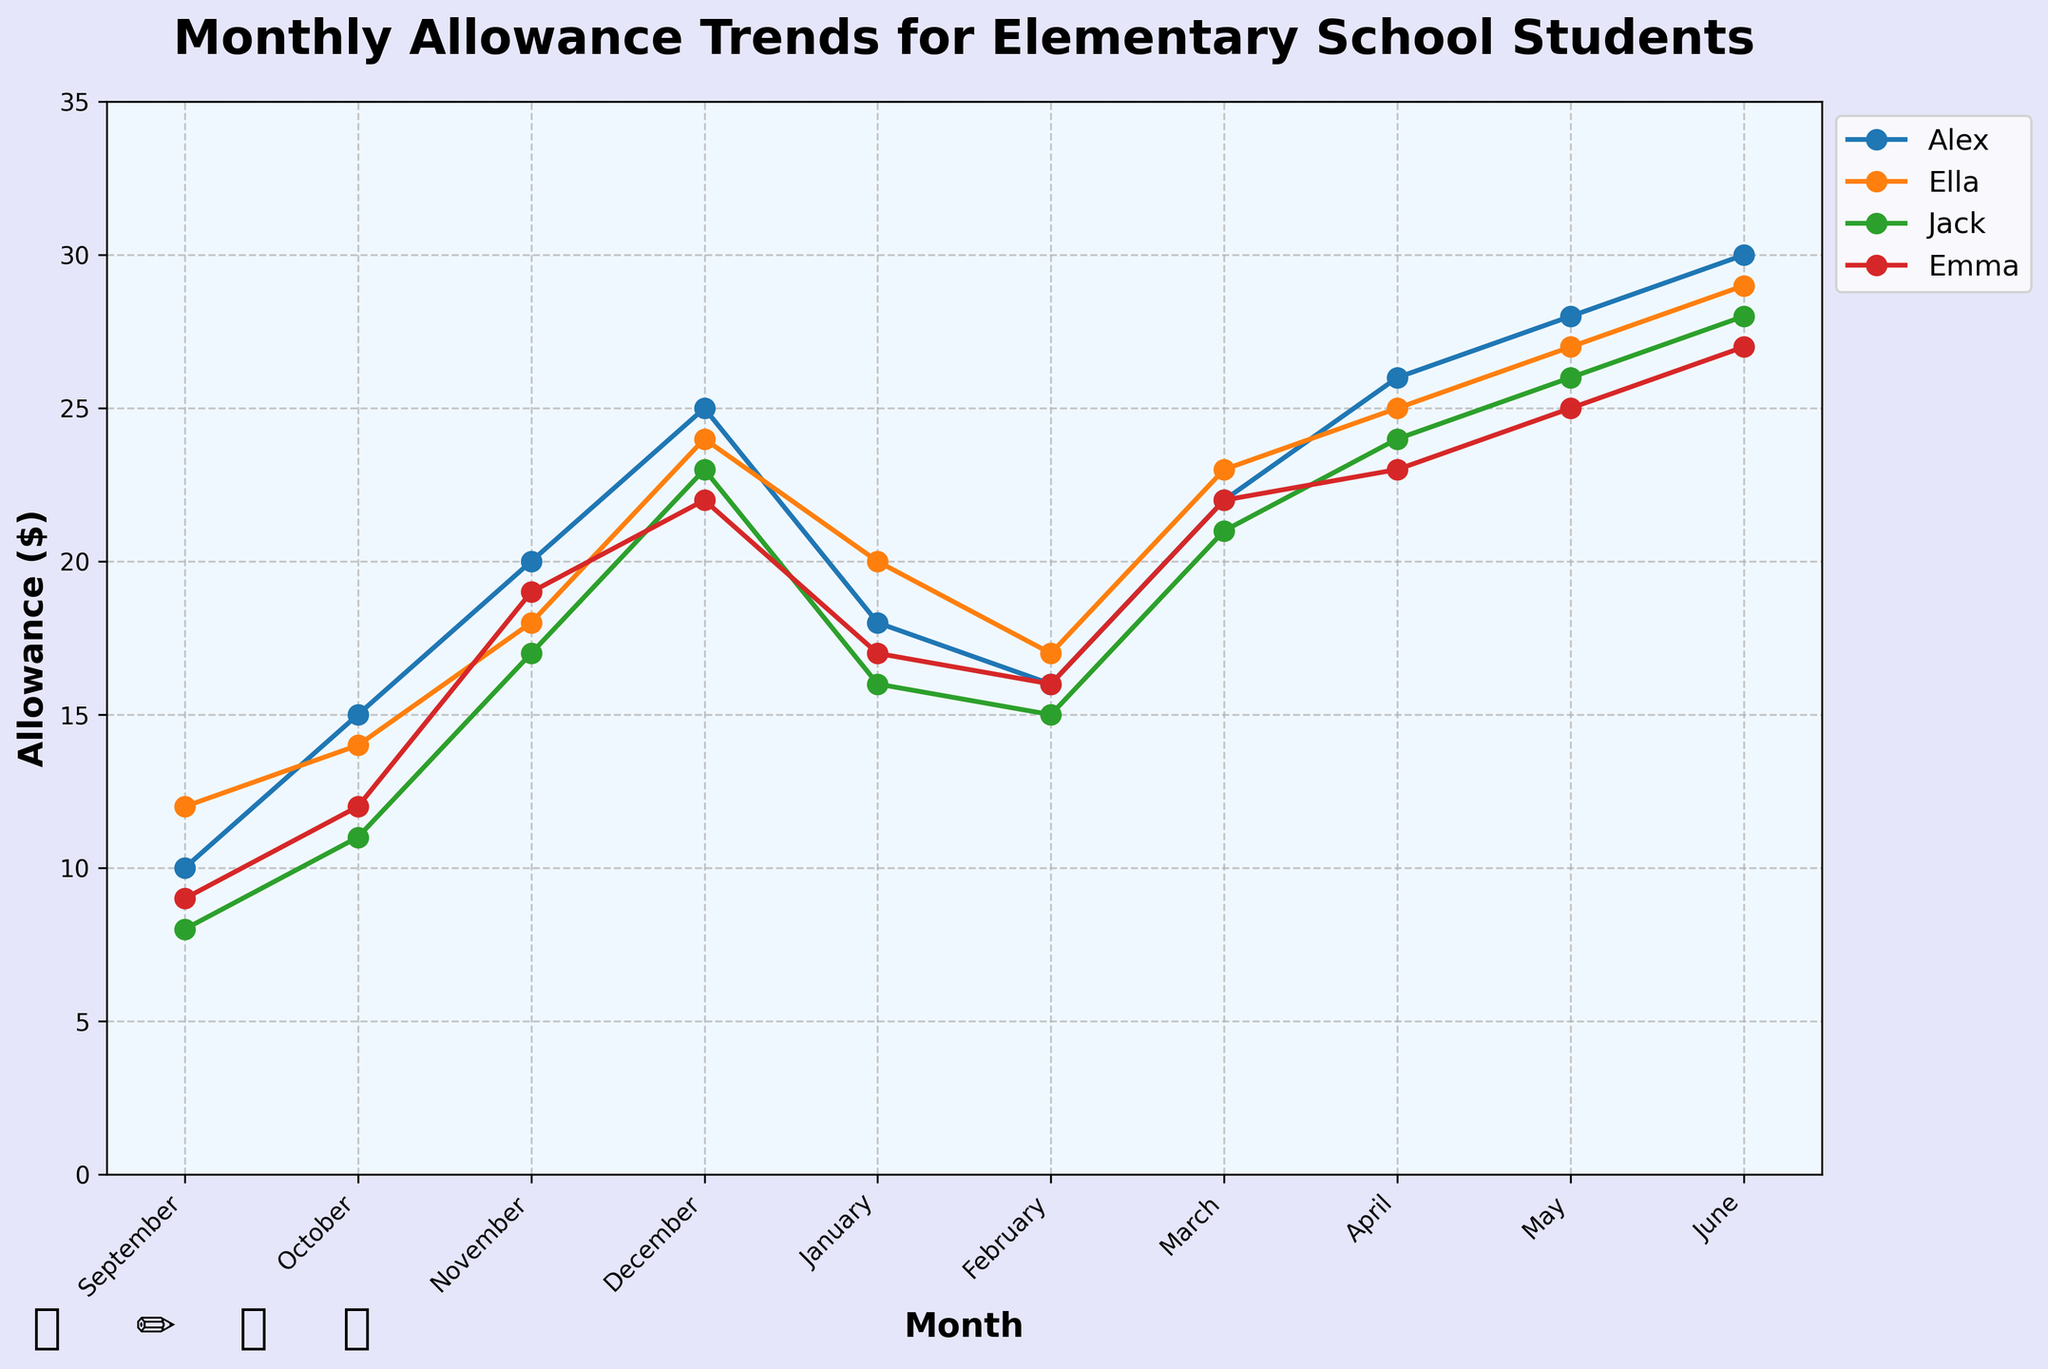What is the title of the plot? The title is displayed at the top of the plot, in large bold text. It helps to understand the main subject of the plot.
Answer: Monthly Allowance Trends for Elementary School Students Which student had the highest allowance in June? By looking at the height of the lines for each student in the month of June, we can compare their allowances. The highest point corresponds to Alex.
Answer: Alex How much allowance did Emma get in January? In January, we can find Emma's allowance by locating her line and seeing where it intersects the January point on the x-axis.
Answer: 17 What is the trend of Alex's allowance from September to December? Observing Alex's line from September to December, we see a consistent upward trend, indicating an increase each month.
Answer: Increasing What is the biggest difference in allowance for Jack across any two consecutive months? To find this, we check the differences in Jack's allowances between every two consecutive months and identify the largest difference: November's (17) and December's (23), which is 6.
Answer: 6 Compare the allowances of Ella and Emma in March. By locating both Ella and Emma's lines in March, and comparing their y-coordinates, we find that they both have the same allowance value.
Answer: Equal Which month shows the largest increase in allowance for Ella compared to the previous month? We check Ella's allowance increases month by month to find the largest jump. The largest increase is from January (20) to March (23), which is 3.
Answer: March What is the average allowance for Alex over the entire school year? Adding up Alex's monthly allowances and dividing by the number of months (9 months) gives us (10 + 15 + 20 + 25 + 18 + 16 + 22 + 26 + 28 + 30) / 9 = 21.
Answer: 21 